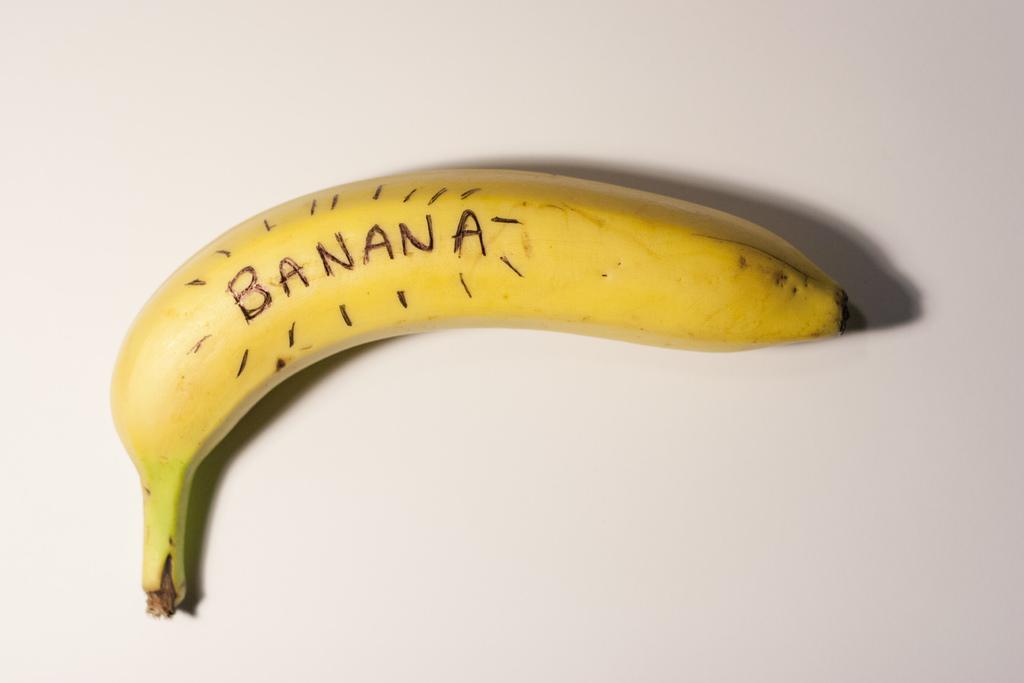Has this piece of fruit been properly identified?
Provide a short and direct response. Yes. This piece of fruit has what word written on it?
Your answer should be compact. Banana. 